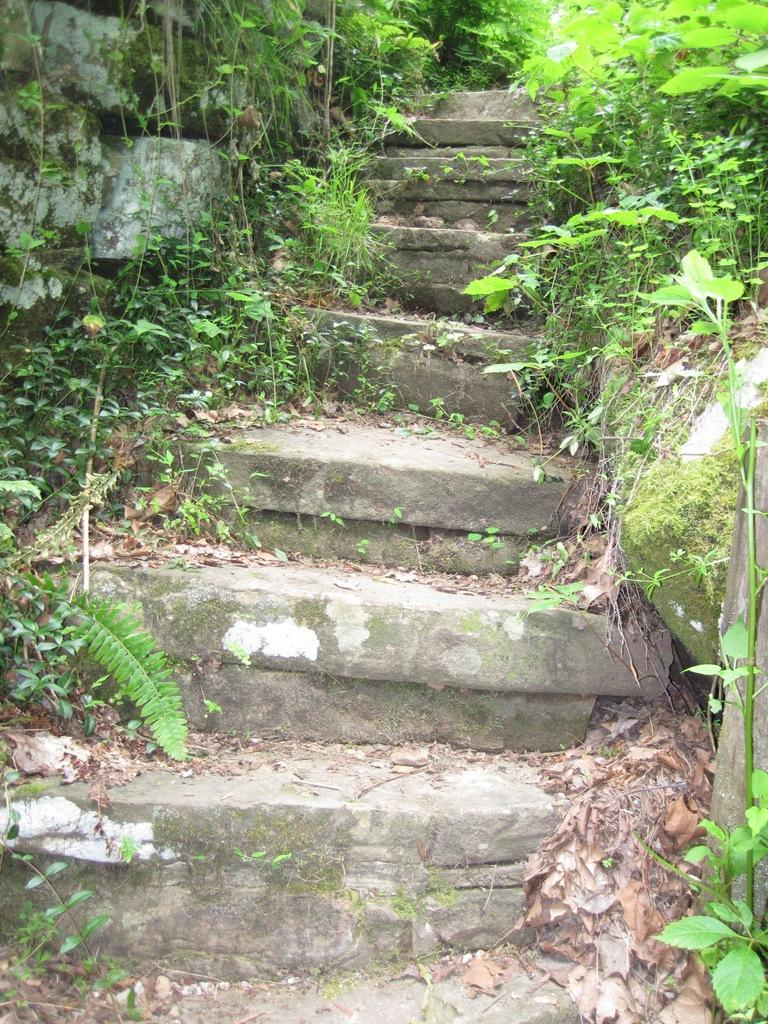What is the main feature in the center of the image? There is a staircase, a wall, plants, dry leaves, and grass in the center of the image. Can you describe the wall in the image? There is a wall in the center of the image. What type of vegetation is present in the center of the image? There are plants and grass visible in the center of the image. What else can be found in the center of the image? Dry leaves are present in the center of the image. What type of wax can be seen melting near the staircase in the image? There is no wax present in the image; it features a staircase, a wall, plants, dry leaves, and grass. 